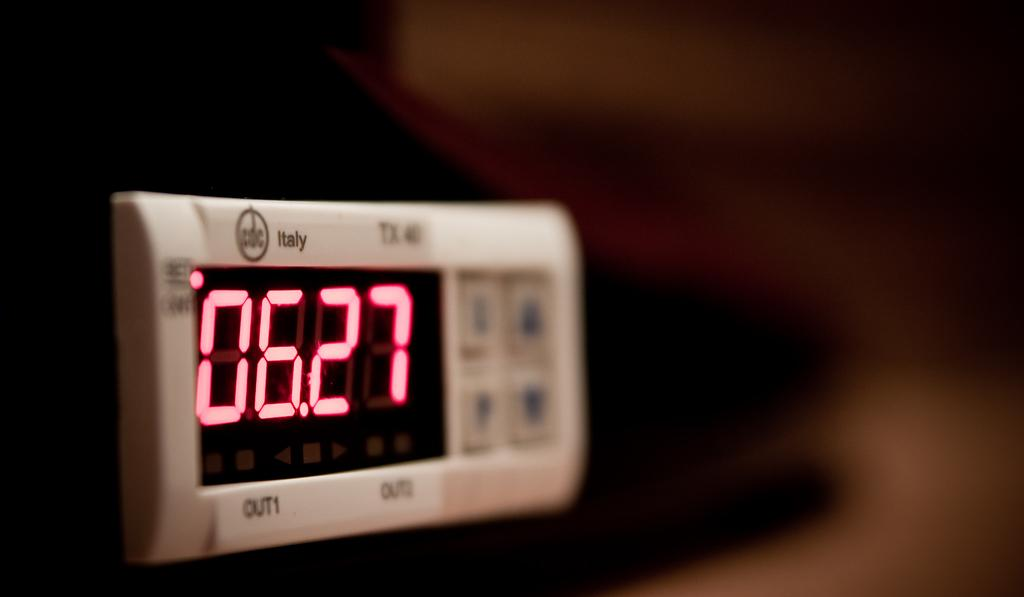Provide a one-sentence caption for the provided image. an Italy beige digital timer clock with pink numbers 06.27. 